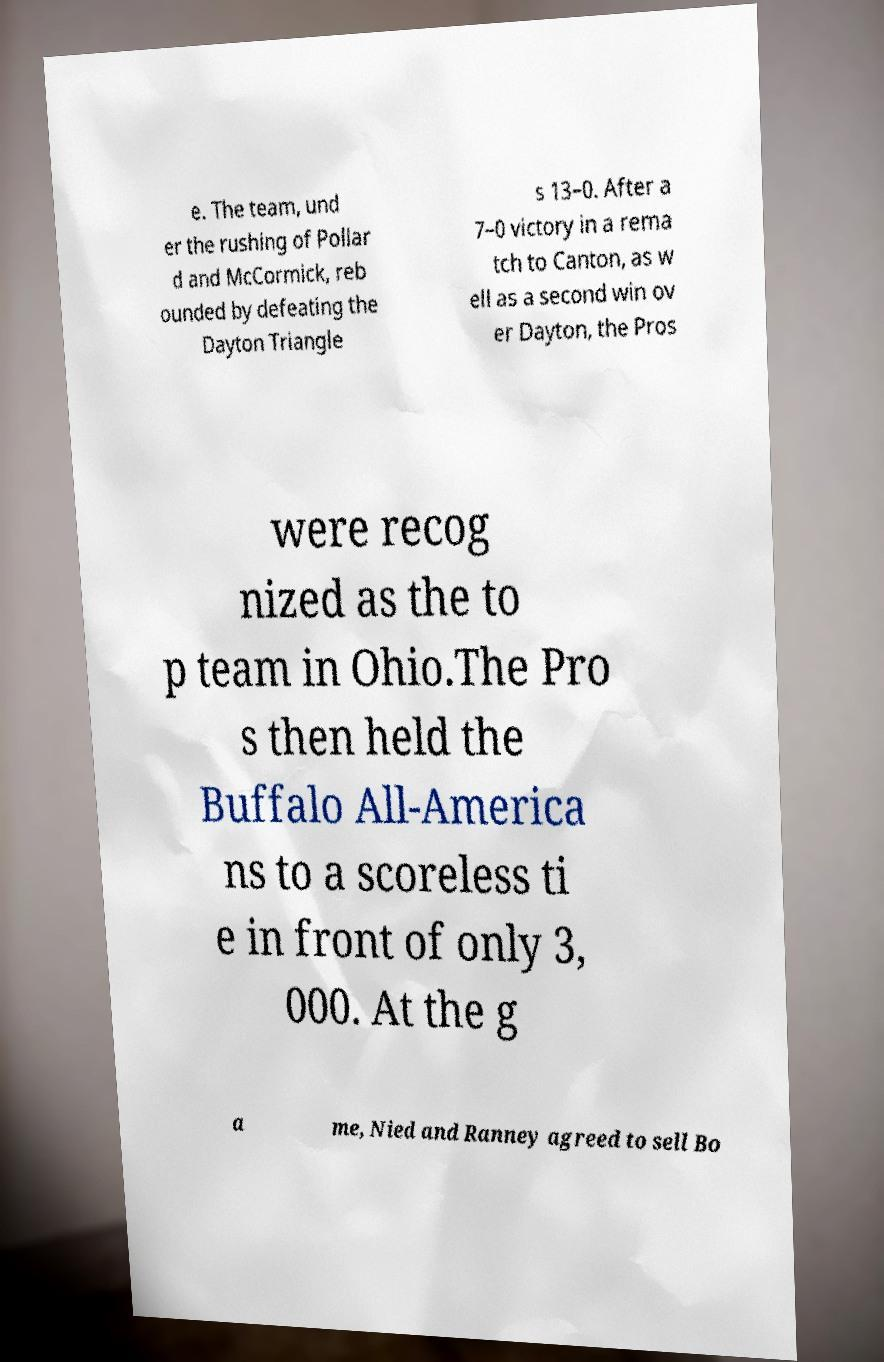Can you read and provide the text displayed in the image?This photo seems to have some interesting text. Can you extract and type it out for me? e. The team, und er the rushing of Pollar d and McCormick, reb ounded by defeating the Dayton Triangle s 13–0. After a 7–0 victory in a rema tch to Canton, as w ell as a second win ov er Dayton, the Pros were recog nized as the to p team in Ohio.The Pro s then held the Buffalo All-America ns to a scoreless ti e in front of only 3, 000. At the g a me, Nied and Ranney agreed to sell Bo 